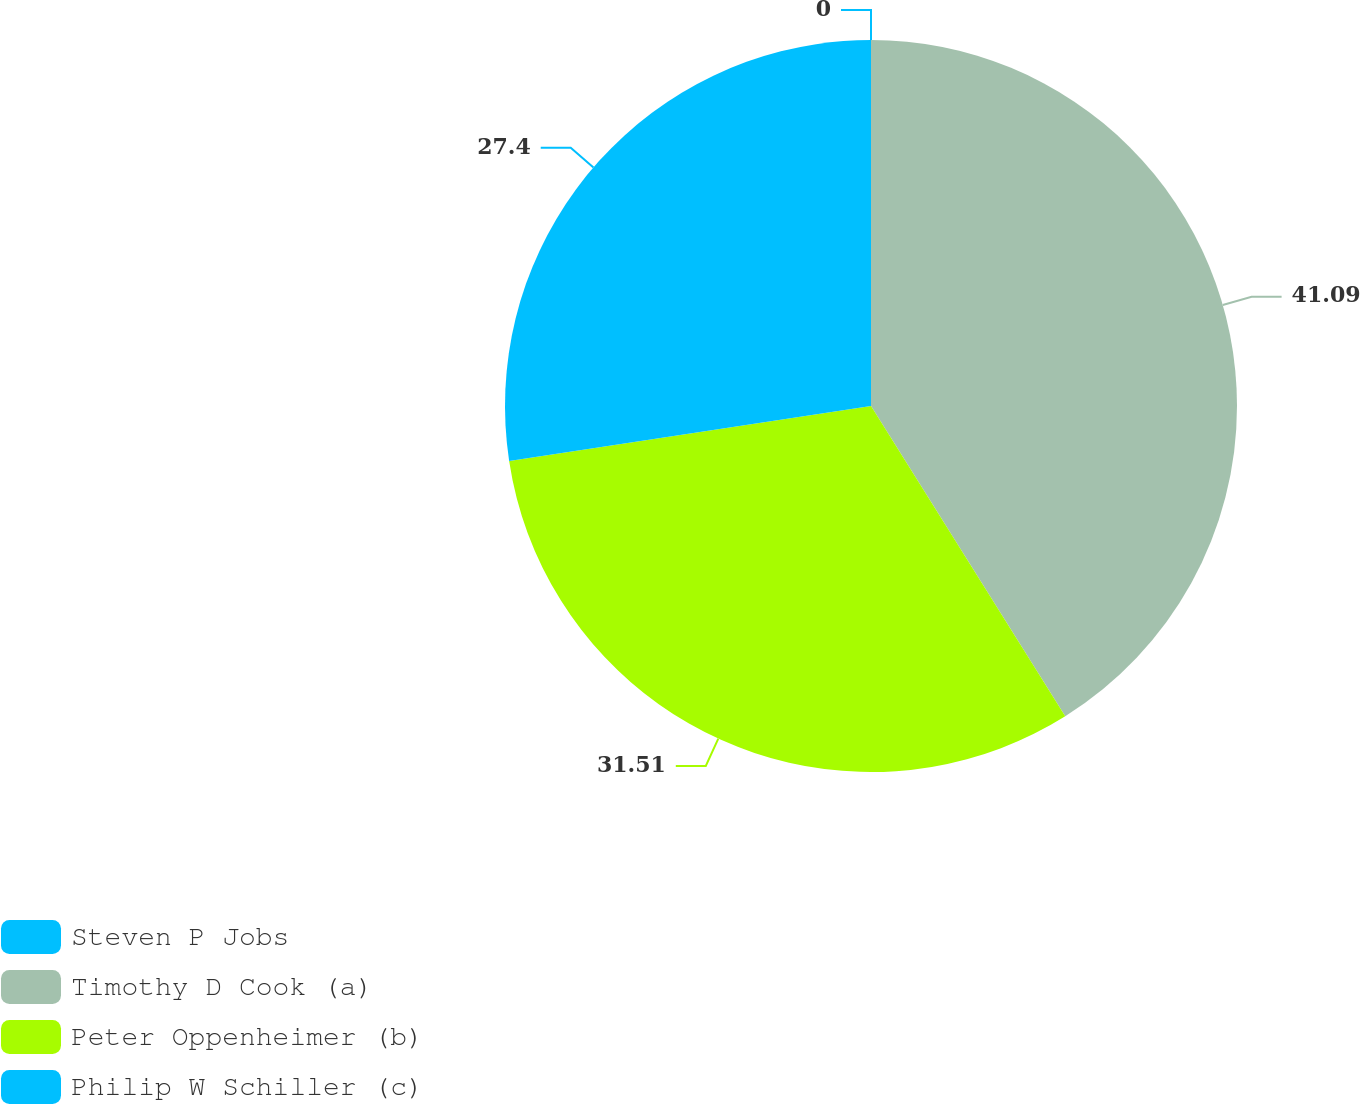Convert chart. <chart><loc_0><loc_0><loc_500><loc_500><pie_chart><fcel>Steven P Jobs<fcel>Timothy D Cook (a)<fcel>Peter Oppenheimer (b)<fcel>Philip W Schiller (c)<nl><fcel>0.0%<fcel>41.1%<fcel>31.51%<fcel>27.4%<nl></chart> 